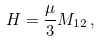<formula> <loc_0><loc_0><loc_500><loc_500>H = \frac { \mu } { 3 } M _ { 1 2 } \, ,</formula> 